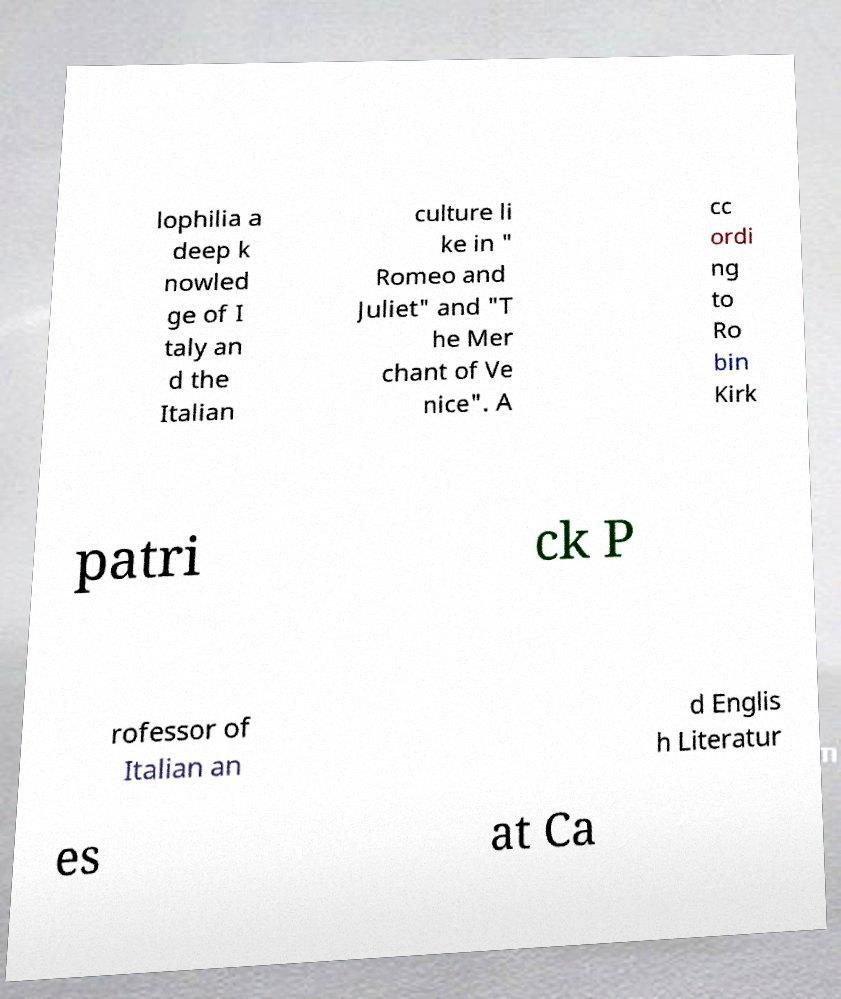Could you assist in decoding the text presented in this image and type it out clearly? lophilia a deep k nowled ge of I taly an d the Italian culture li ke in " Romeo and Juliet" and "T he Mer chant of Ve nice". A cc ordi ng to Ro bin Kirk patri ck P rofessor of Italian an d Englis h Literatur es at Ca 